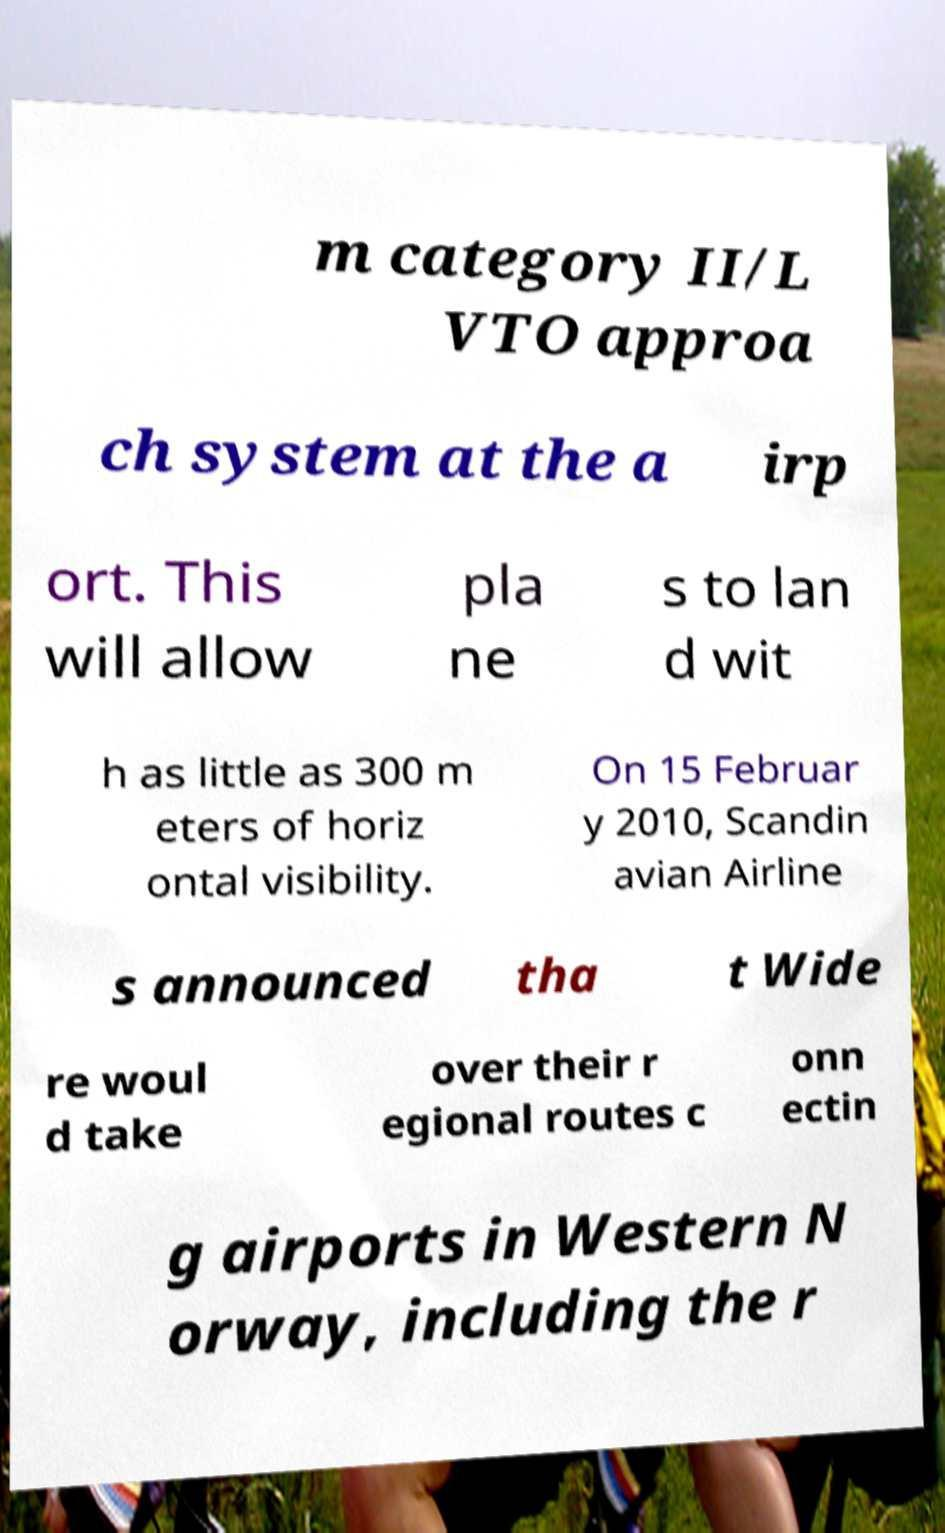Please read and relay the text visible in this image. What does it say? m category II/L VTO approa ch system at the a irp ort. This will allow pla ne s to lan d wit h as little as 300 m eters of horiz ontal visibility. On 15 Februar y 2010, Scandin avian Airline s announced tha t Wide re woul d take over their r egional routes c onn ectin g airports in Western N orway, including the r 